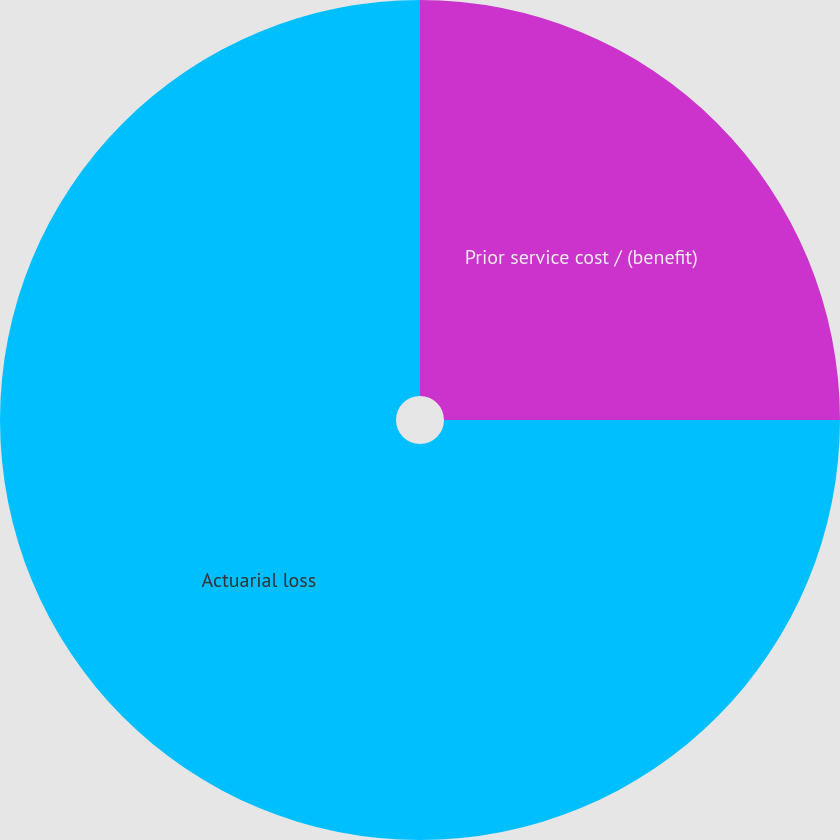Convert chart to OTSL. <chart><loc_0><loc_0><loc_500><loc_500><pie_chart><fcel>Prior service cost / (benefit)<fcel>Actuarial loss<nl><fcel>25.0%<fcel>75.0%<nl></chart> 